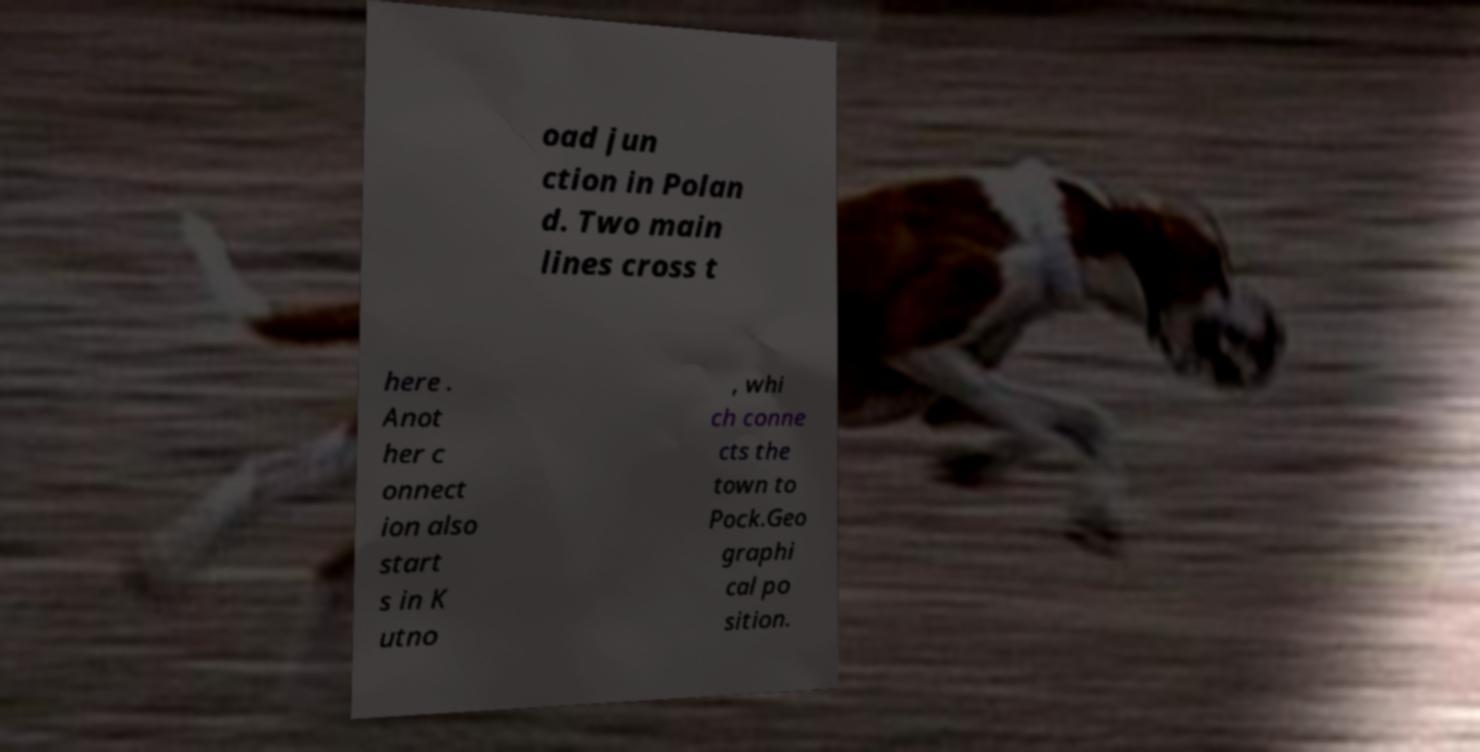I need the written content from this picture converted into text. Can you do that? oad jun ction in Polan d. Two main lines cross t here . Anot her c onnect ion also start s in K utno , whi ch conne cts the town to Pock.Geo graphi cal po sition. 